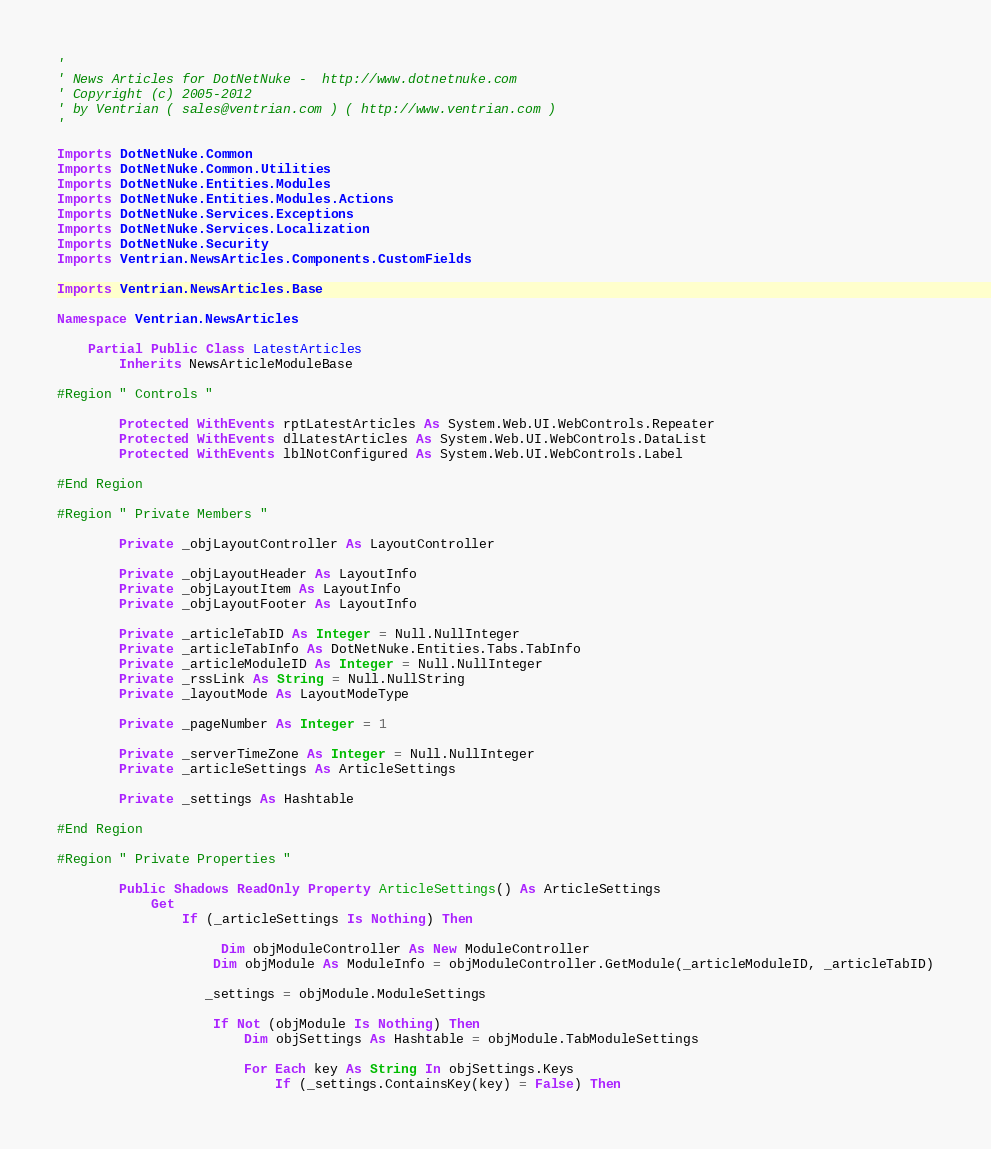<code> <loc_0><loc_0><loc_500><loc_500><_VisualBasic_>'
' News Articles for DotNetNuke -  http://www.dotnetnuke.com
' Copyright (c) 2005-2012
' by Ventrian ( sales@ventrian.com ) ( http://www.ventrian.com )
'

Imports DotNetNuke.Common
Imports DotNetNuke.Common.Utilities
Imports DotNetNuke.Entities.Modules
Imports DotNetNuke.Entities.Modules.Actions
Imports DotNetNuke.Services.Exceptions
Imports DotNetNuke.Services.Localization
Imports DotNetNuke.Security
Imports Ventrian.NewsArticles.Components.CustomFields

Imports Ventrian.NewsArticles.Base

Namespace Ventrian.NewsArticles

    Partial Public Class LatestArticles
        Inherits NewsArticleModuleBase

#Region " Controls "

        Protected WithEvents rptLatestArticles As System.Web.UI.WebControls.Repeater
        Protected WithEvents dlLatestArticles As System.Web.UI.WebControls.DataList
        Protected WithEvents lblNotConfigured As System.Web.UI.WebControls.Label

#End Region

#Region " Private Members "

        Private _objLayoutController As LayoutController

        Private _objLayoutHeader As LayoutInfo
        Private _objLayoutItem As LayoutInfo
        Private _objLayoutFooter As LayoutInfo

        Private _articleTabID As Integer = Null.NullInteger
        Private _articleTabInfo As DotNetNuke.Entities.Tabs.TabInfo
        Private _articleModuleID As Integer = Null.NullInteger
        Private _rssLink As String = Null.NullString
        Private _layoutMode As LayoutModeType

        Private _pageNumber As Integer = 1

        Private _serverTimeZone As Integer = Null.NullInteger
        Private _articleSettings As ArticleSettings

        Private _settings As Hashtable

#End Region

#Region " Private Properties "

        Public Shadows ReadOnly Property ArticleSettings() As ArticleSettings
            Get
                If (_articleSettings Is Nothing) Then

                     Dim objModuleController As New ModuleController
                    Dim objModule As ModuleInfo = objModuleController.GetModule(_articleModuleID, _articleTabID)

                   _settings = objModule.ModuleSettings

                    If Not (objModule Is Nothing) Then
                        Dim objSettings As Hashtable = objModule.TabModuleSettings

                        For Each key As String In objSettings.Keys
                            If (_settings.ContainsKey(key) = False) Then</code> 